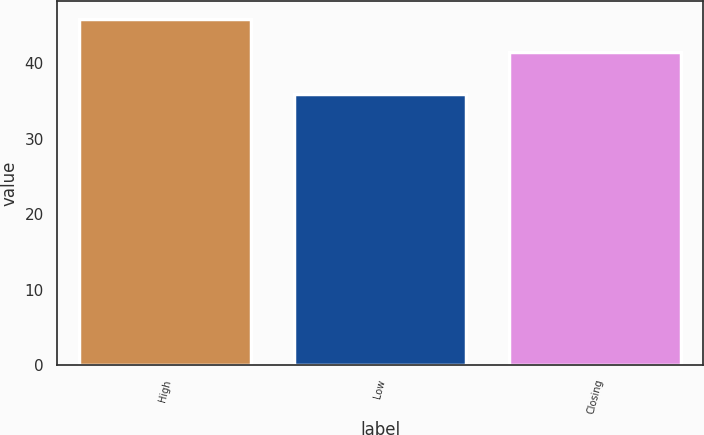Convert chart to OTSL. <chart><loc_0><loc_0><loc_500><loc_500><bar_chart><fcel>High<fcel>Low<fcel>Closing<nl><fcel>45.93<fcel>35.98<fcel>41.57<nl></chart> 